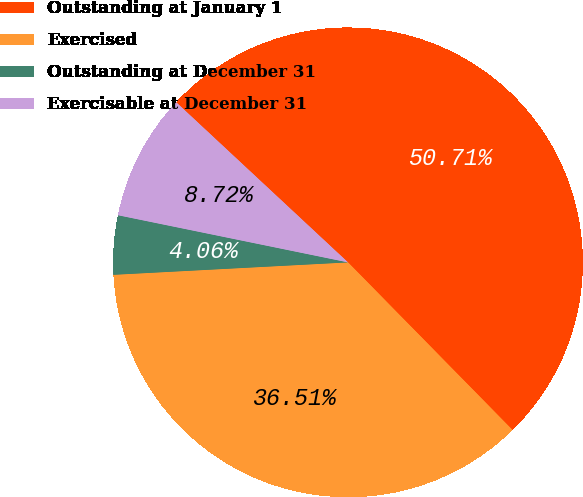Convert chart. <chart><loc_0><loc_0><loc_500><loc_500><pie_chart><fcel>Outstanding at January 1<fcel>Exercised<fcel>Outstanding at December 31<fcel>Exercisable at December 31<nl><fcel>50.71%<fcel>36.51%<fcel>4.06%<fcel>8.72%<nl></chart> 